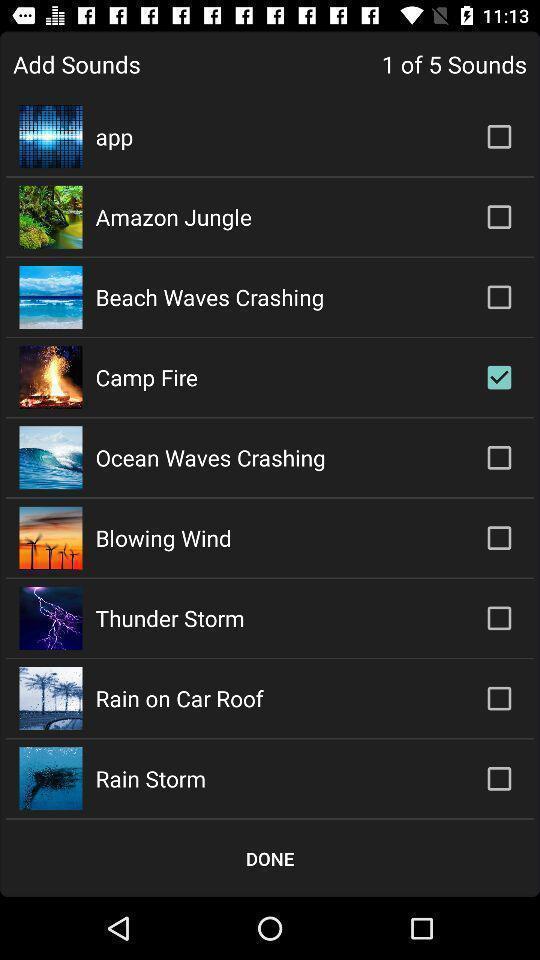Explain the elements present in this screenshot. Screen page of a list of sounds. 